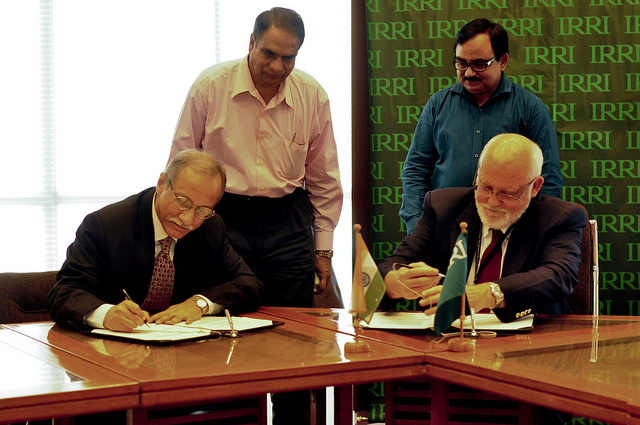How many men are sitting down? There are two men sitting down at a table, actively engaged in what appears to be a signing ceremony, with documents in front of them and pens in hand. 